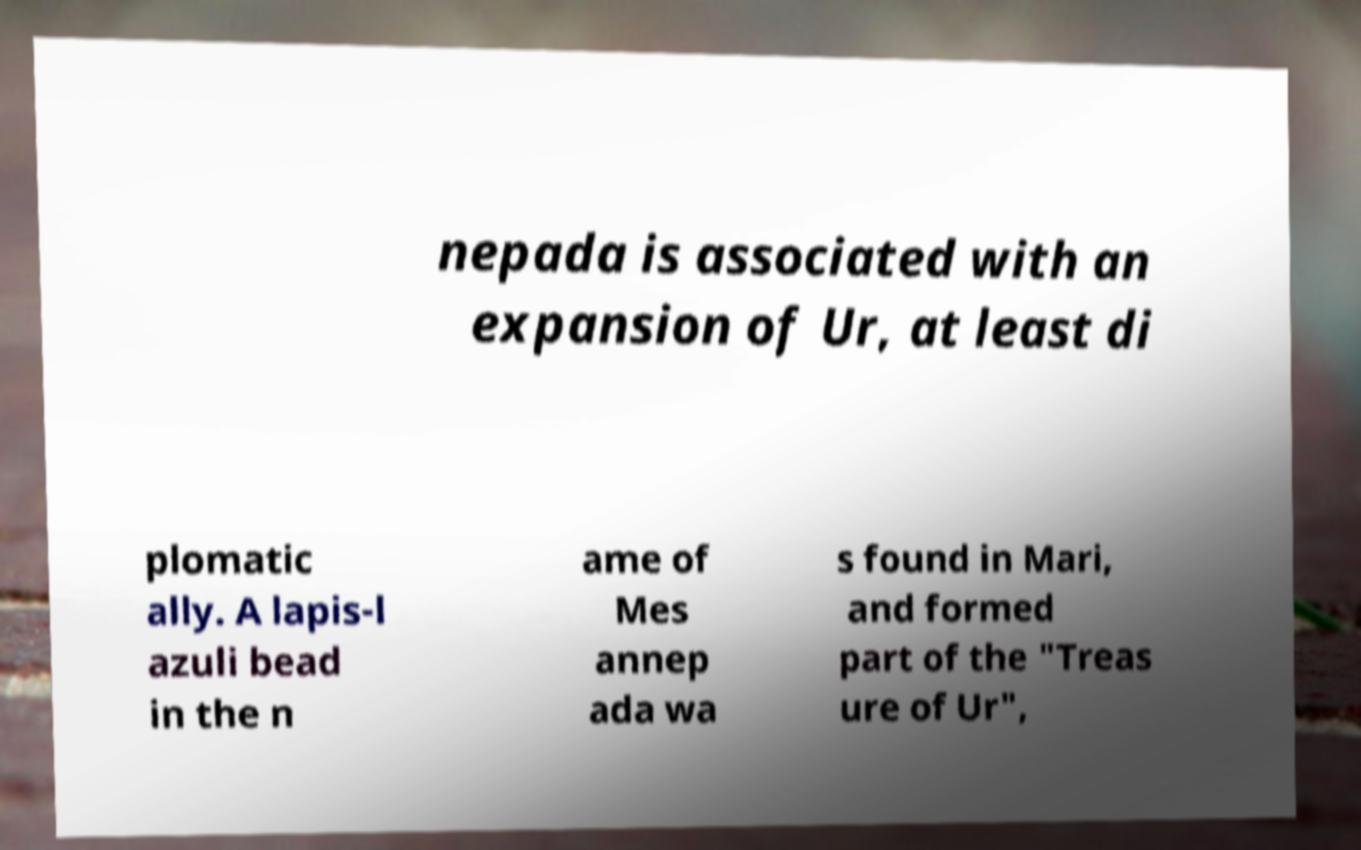Can you read and provide the text displayed in the image?This photo seems to have some interesting text. Can you extract and type it out for me? nepada is associated with an expansion of Ur, at least di plomatic ally. A lapis-l azuli bead in the n ame of Mes annep ada wa s found in Mari, and formed part of the "Treas ure of Ur", 